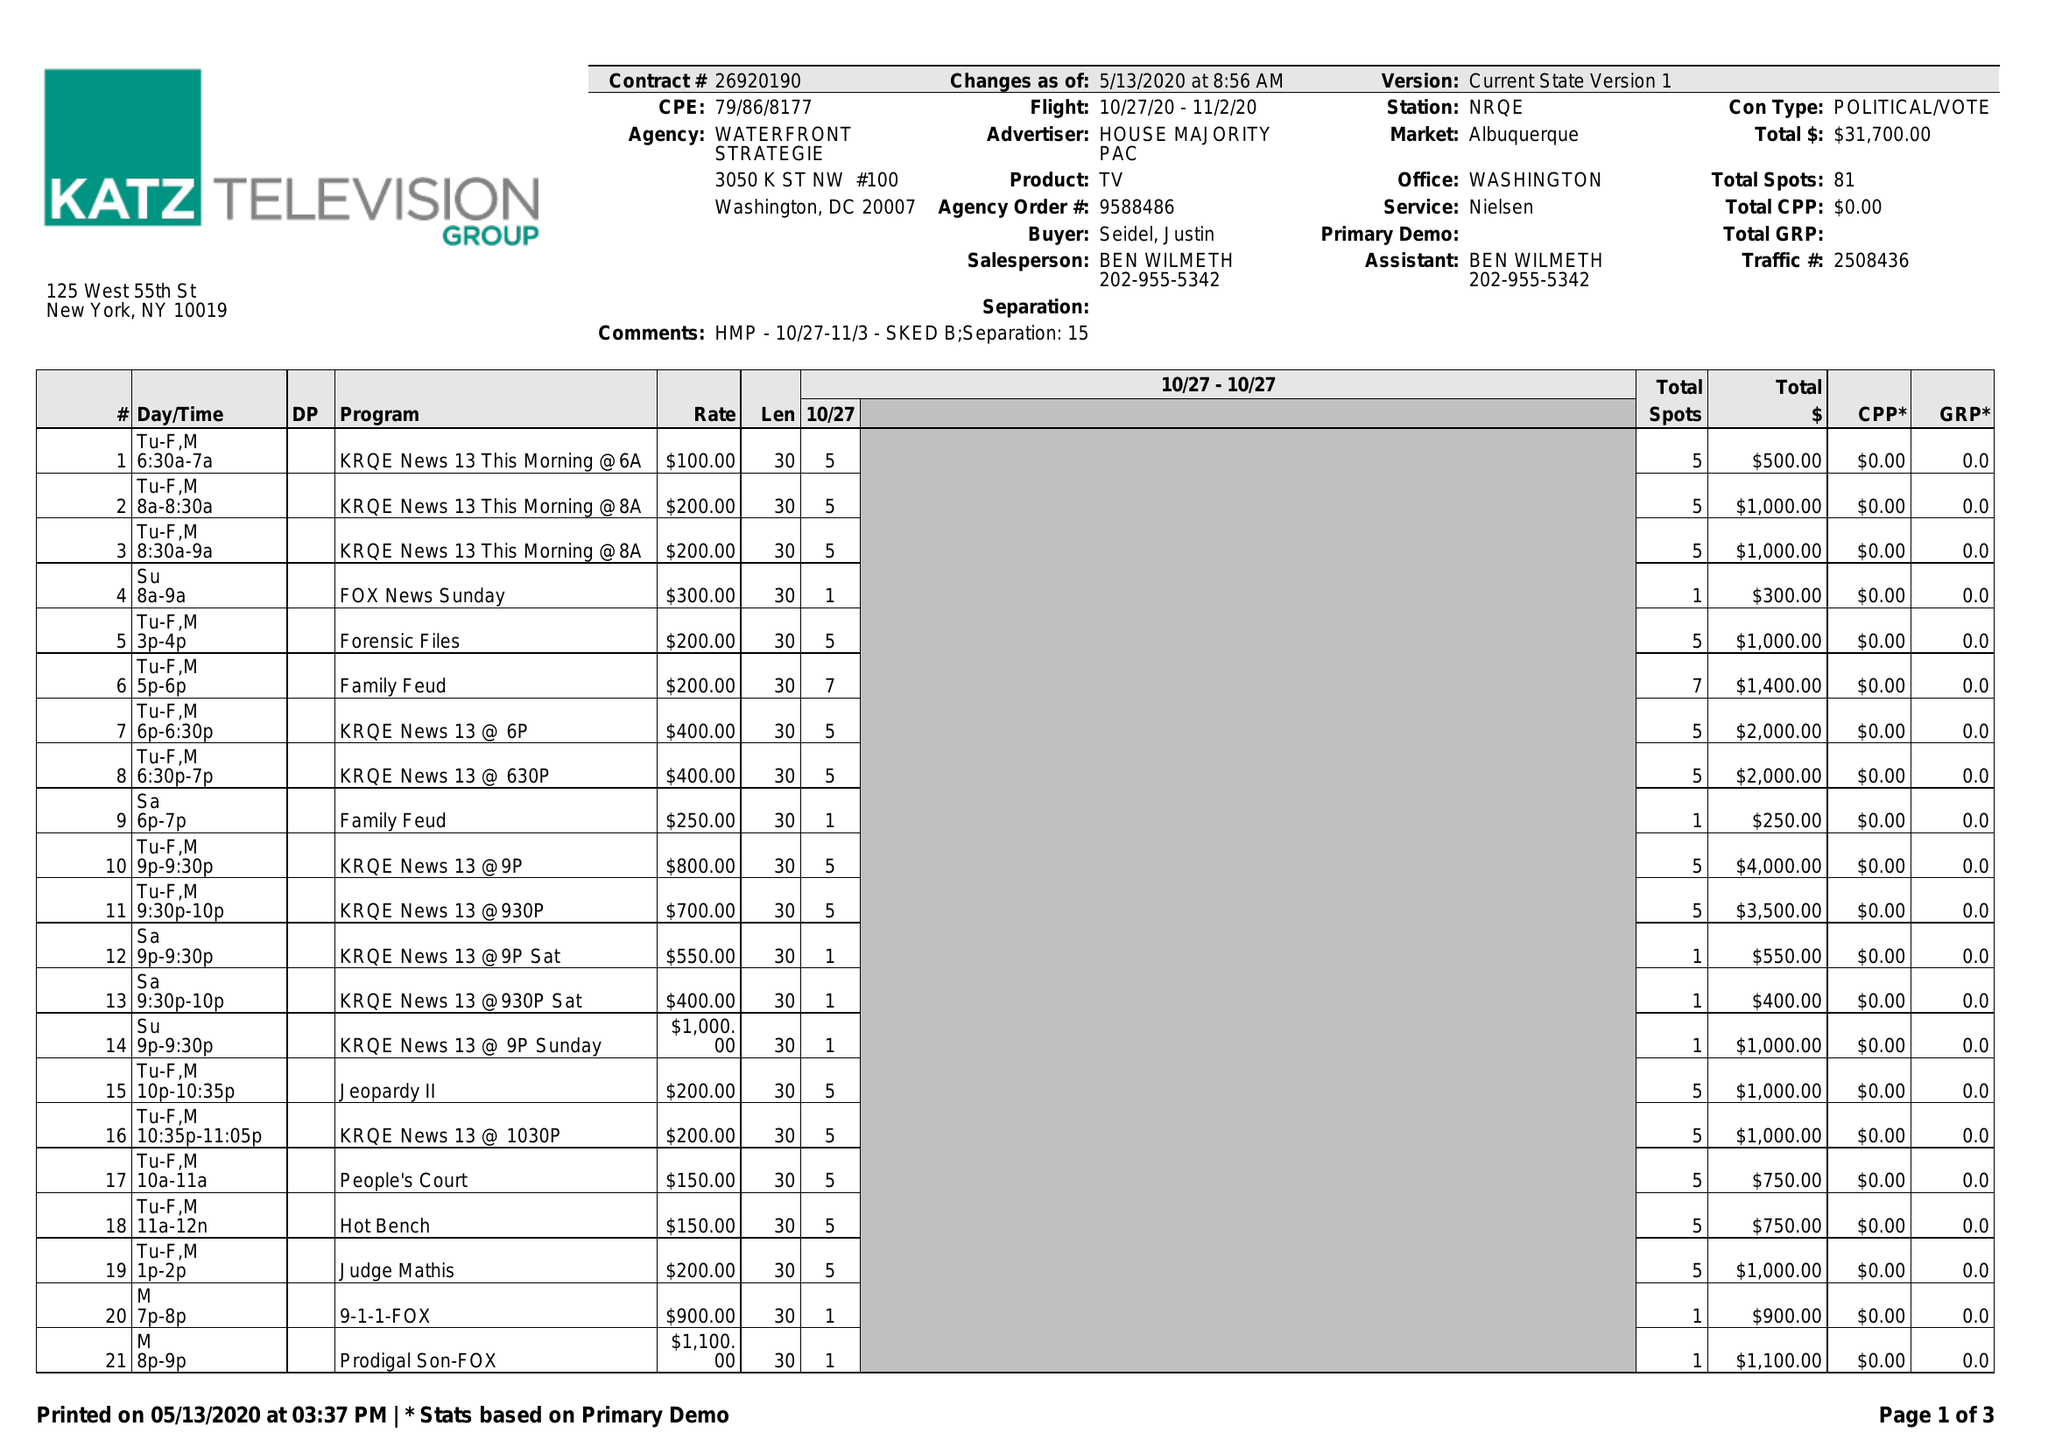What is the value for the advertiser?
Answer the question using a single word or phrase. HOUSE MAJORITY PAC 